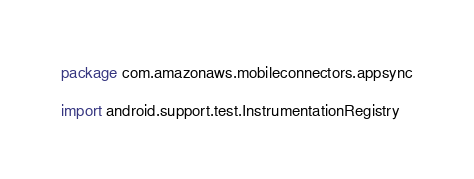Convert code to text. <code><loc_0><loc_0><loc_500><loc_500><_Kotlin_>package com.amazonaws.mobileconnectors.appsync

import android.support.test.InstrumentationRegistry</code> 